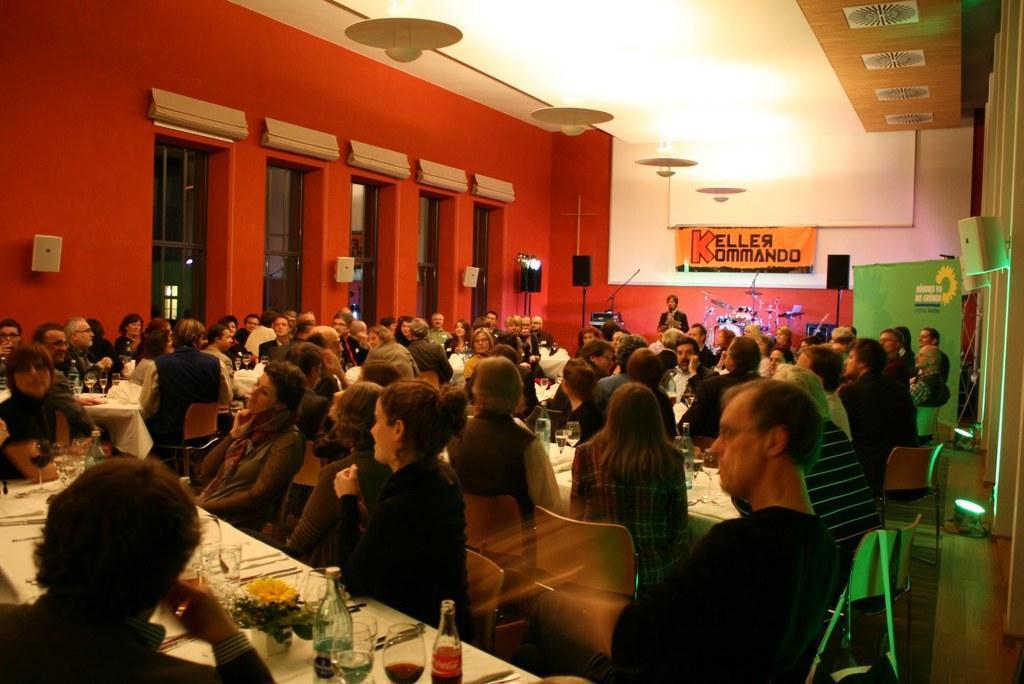Describe this image in one or two sentences. In this picture, There are some tables which are in white color, There are some people sitting on the chairs, in the background there is a red color wall and there are some windows which are in black color and in the top there is a roof in white color and there are some lights in yellow color. 